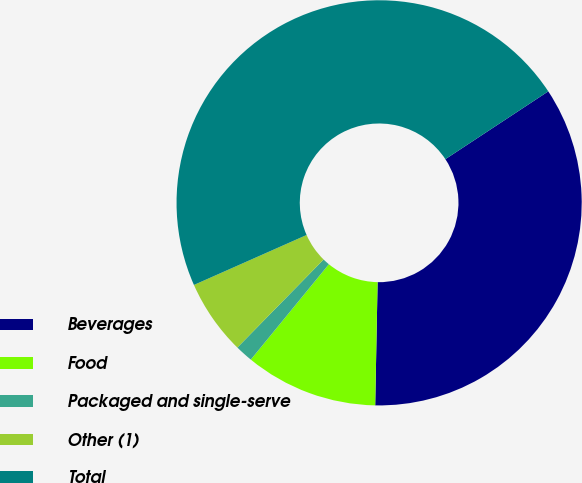<chart> <loc_0><loc_0><loc_500><loc_500><pie_chart><fcel>Beverages<fcel>Food<fcel>Packaged and single-serve<fcel>Other (1)<fcel>Total<nl><fcel>34.58%<fcel>10.61%<fcel>1.42%<fcel>6.02%<fcel>47.37%<nl></chart> 